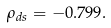<formula> <loc_0><loc_0><loc_500><loc_500>\rho _ { d s } = - 0 . 7 9 9 .</formula> 